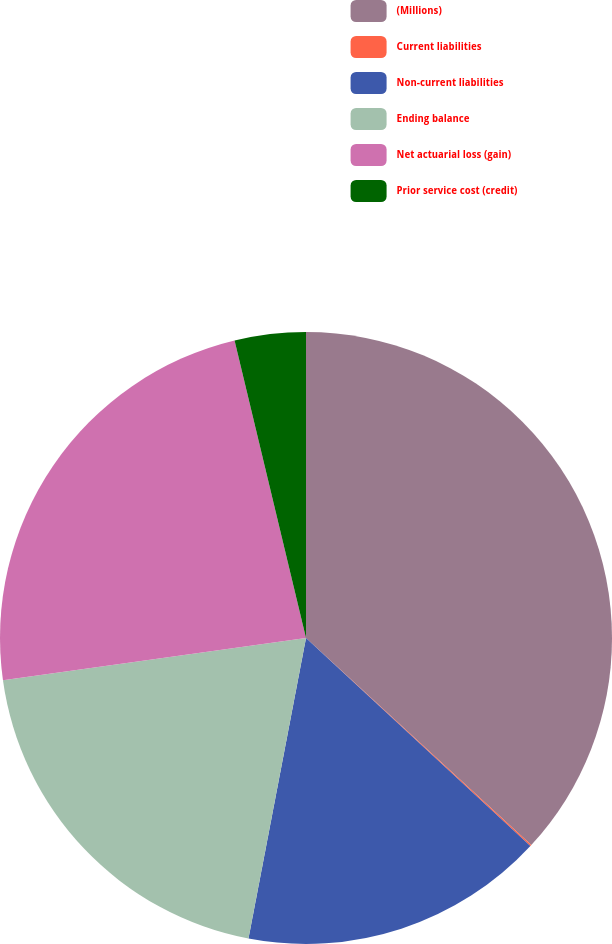<chart> <loc_0><loc_0><loc_500><loc_500><pie_chart><fcel>(Millions)<fcel>Current liabilities<fcel>Non-current liabilities<fcel>Ending balance<fcel>Net actuarial loss (gain)<fcel>Prior service cost (credit)<nl><fcel>36.83%<fcel>0.07%<fcel>16.11%<fcel>19.78%<fcel>23.46%<fcel>3.75%<nl></chart> 